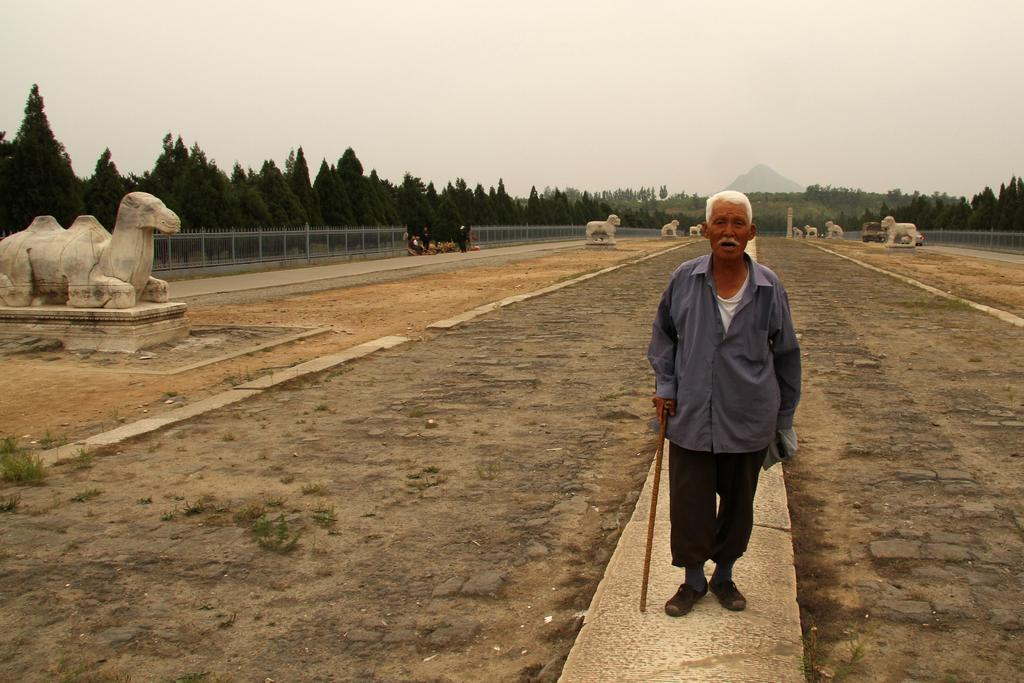What is the person in the image holding? The person in the image is holding a walking stick. What type of artwork can be seen in the image? There are sculptures in the image. What type of barrier is present in the image? There is fencing in the image. What type of vegetation is present in the image? There are trees and plants in the image. What geographical feature is visible in the image? There is a mountain visible in the image. What part of the natural environment is visible in the image? The sky is visible in the image. What type of stew is being served in the image? There is no stew present in the image. What type of office equipment can be seen in the image? There is no office equipment present in the image. 